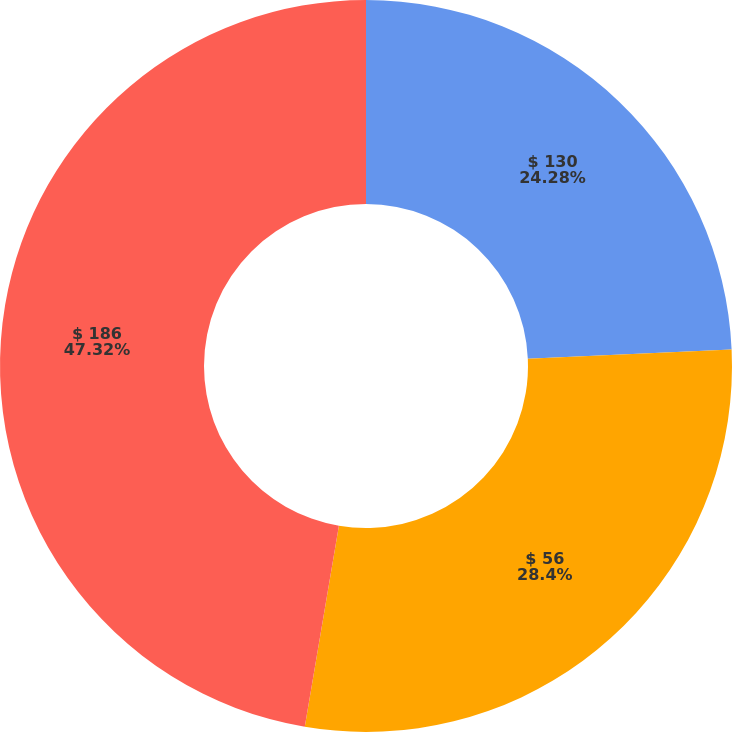<chart> <loc_0><loc_0><loc_500><loc_500><pie_chart><fcel>$ 130<fcel>$ 56<fcel>$ 186<nl><fcel>24.28%<fcel>28.4%<fcel>47.33%<nl></chart> 